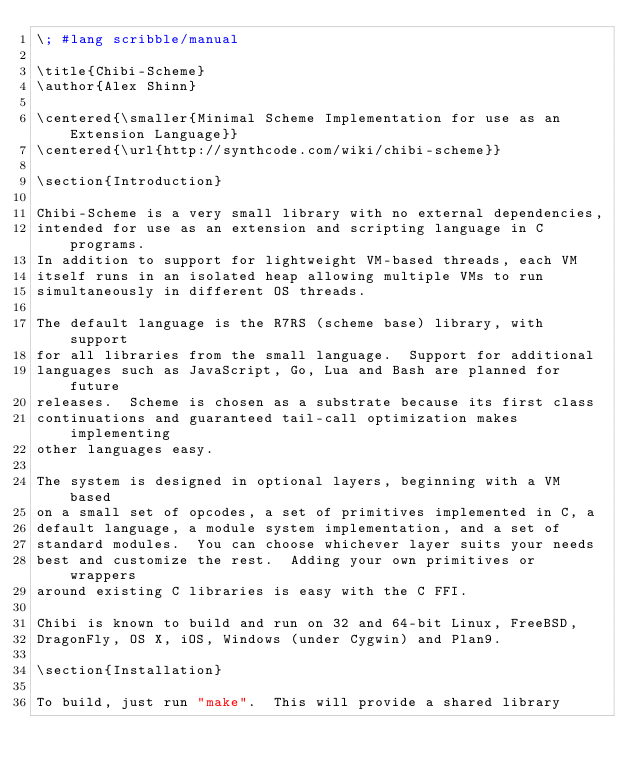<code> <loc_0><loc_0><loc_500><loc_500><_Racket_>\; #lang scribble/manual

\title{Chibi-Scheme}
\author{Alex Shinn}

\centered{\smaller{Minimal Scheme Implementation for use as an Extension Language}}
\centered{\url{http://synthcode.com/wiki/chibi-scheme}}

\section{Introduction}

Chibi-Scheme is a very small library with no external dependencies,
intended for use as an extension and scripting language in C programs.
In addition to support for lightweight VM-based threads, each VM
itself runs in an isolated heap allowing multiple VMs to run
simultaneously in different OS threads.

The default language is the R7RS (scheme base) library, with support
for all libraries from the small language.  Support for additional
languages such as JavaScript, Go, Lua and Bash are planned for future
releases.  Scheme is chosen as a substrate because its first class
continuations and guaranteed tail-call optimization makes implementing
other languages easy.

The system is designed in optional layers, beginning with a VM based
on a small set of opcodes, a set of primitives implemented in C, a
default language, a module system implementation, and a set of
standard modules.  You can choose whichever layer suits your needs
best and customize the rest.  Adding your own primitives or wrappers
around existing C libraries is easy with the C FFI.

Chibi is known to build and run on 32 and 64-bit Linux, FreeBSD,
DragonFly, OS X, iOS, Windows (under Cygwin) and Plan9.

\section{Installation}

To build, just run "make".  This will provide a shared library</code> 